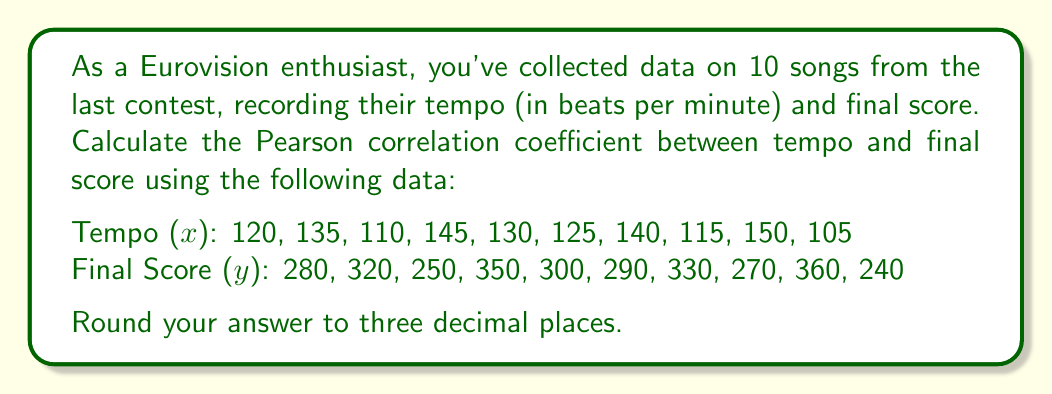Provide a solution to this math problem. To calculate the Pearson correlation coefficient (r), we'll use the formula:

$$ r = \frac{n\sum xy - \sum x \sum y}{\sqrt{[n\sum x^2 - (\sum x)^2][n\sum y^2 - (\sum y)^2]}} $$

Where n is the number of data points.

Step 1: Calculate the sums and squared sums:
$\sum x = 1275$
$\sum y = 2990$
$\sum x^2 = 165,125$
$\sum y^2 = 910,600$
$\sum xy = 384,950$

Step 2: Calculate $n\sum xy$:
$10 * 384,950 = 3,849,500$

Step 3: Calculate $\sum x \sum y$:
$1275 * 2990 = 3,812,250$

Step 4: Calculate the numerator:
$3,849,500 - 3,812,250 = 37,250$

Step 5: Calculate the parts of the denominator:
$10 * 165,125 - 1275^2 = 1,651,250 - 1,625,625 = 25,625$
$10 * 910,600 - 2990^2 = 9,106,000 - 8,940,100 = 165,900$

Step 6: Calculate the full denominator:
$\sqrt{25,625 * 165,900} = \sqrt{4,251,187,500} = 65,201.44$

Step 7: Divide the numerator by the denominator:
$37,250 / 65,201.44 = 0.5712$

Step 8: Round to three decimal places:
$0.571$
Answer: $0.571$ 